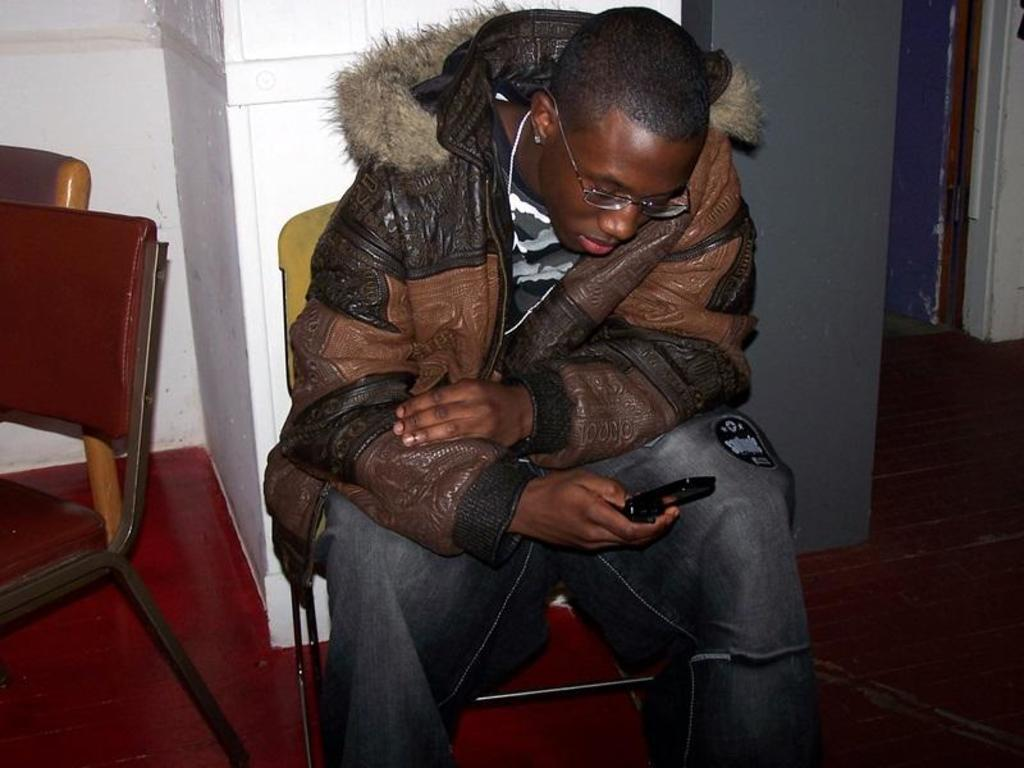What is the person in the image doing? The person is sitting on a chair in the image. What is the person holding in their hand? The person is holding a mobile phone in one hand. What can be seen in the background of the image? There are walls and chairs in the background of the image. Is there an umbrella visible in the image? No, there is no umbrella present in the image. What type of light source is illuminating the person in the image? The provided facts do not mention any light source, so it cannot be determined from the image. 